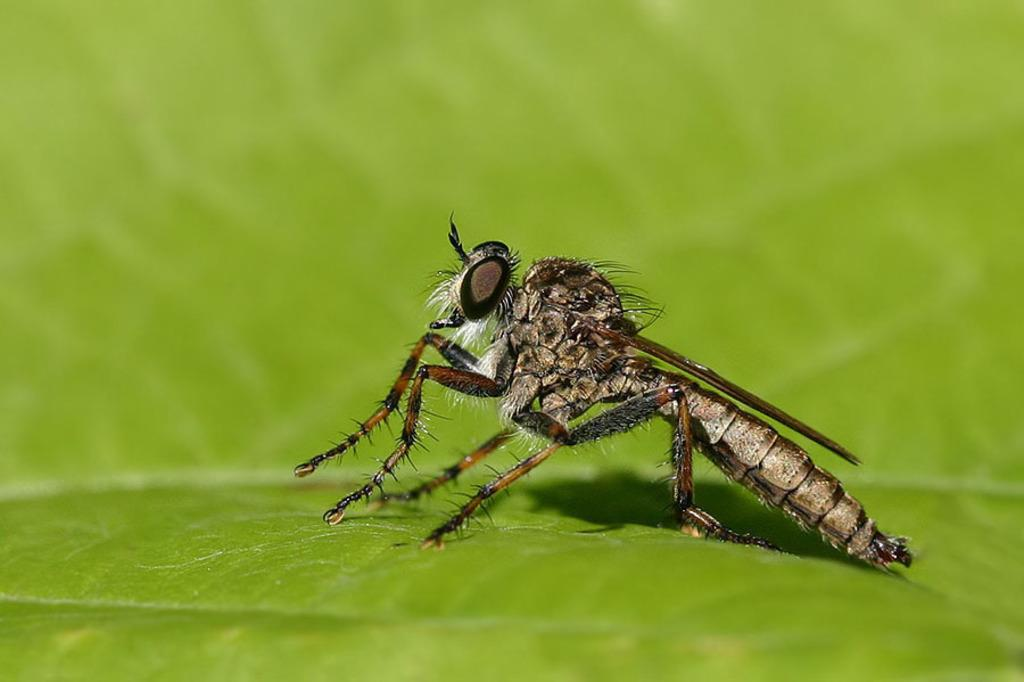What is the main subject of the image? There is an insect in the image. Where is the insect located? The insect is on a leaf. Can you describe the position of the insect in the image? The insect is in the center of the image. What type of grass is the insect using to communicate with its friends? There is no grass present in the image, and insects do not communicate using grass. 